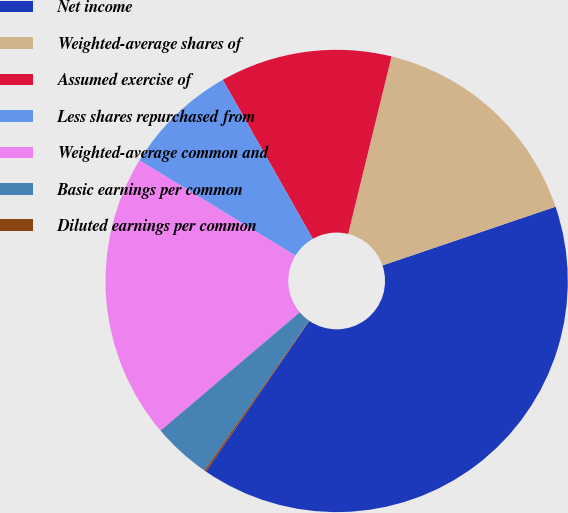Convert chart to OTSL. <chart><loc_0><loc_0><loc_500><loc_500><pie_chart><fcel>Net income<fcel>Weighted-average shares of<fcel>Assumed exercise of<fcel>Less shares repurchased from<fcel>Weighted-average common and<fcel>Basic earnings per common<fcel>Diluted earnings per common<nl><fcel>39.77%<fcel>15.98%<fcel>12.02%<fcel>8.06%<fcel>19.95%<fcel>4.09%<fcel>0.13%<nl></chart> 